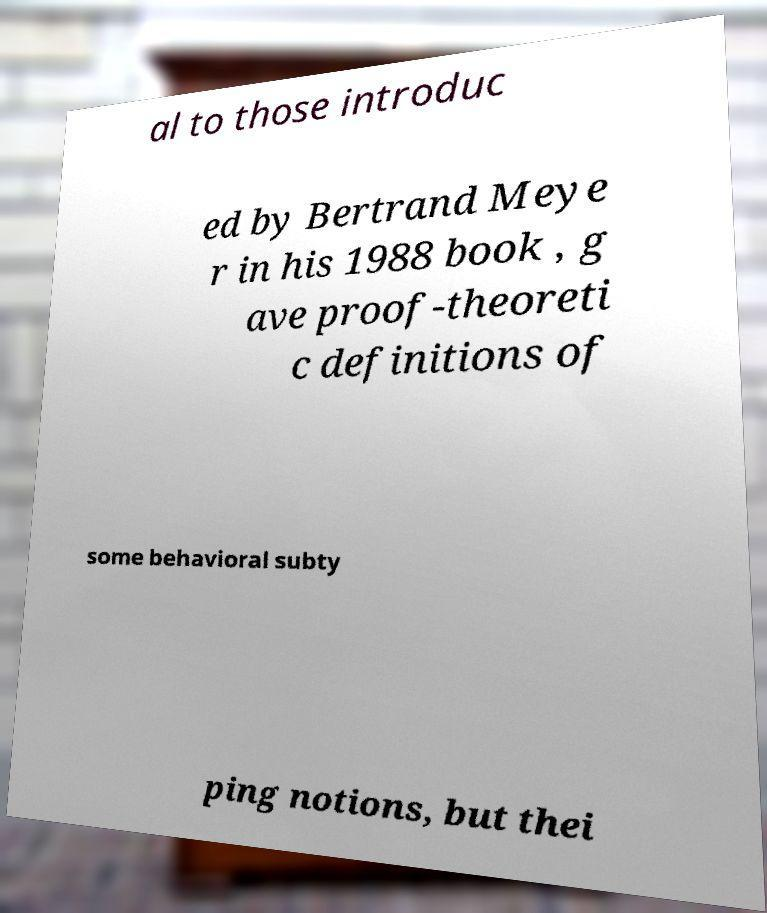I need the written content from this picture converted into text. Can you do that? al to those introduc ed by Bertrand Meye r in his 1988 book , g ave proof-theoreti c definitions of some behavioral subty ping notions, but thei 